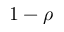Convert formula to latex. <formula><loc_0><loc_0><loc_500><loc_500>1 - \rho</formula> 